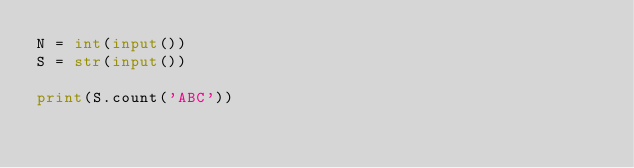Convert code to text. <code><loc_0><loc_0><loc_500><loc_500><_Python_>N = int(input())
S = str(input())

print(S.count('ABC'))</code> 